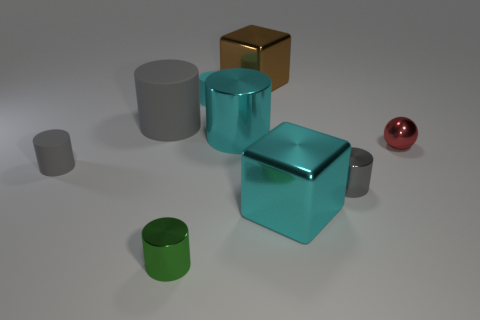Subtract all red spheres. How many gray cylinders are left? 3 Subtract all small cyan cylinders. How many cylinders are left? 5 Subtract all green cylinders. How many cylinders are left? 5 Subtract all red cylinders. Subtract all red spheres. How many cylinders are left? 6 Add 1 small purple matte cylinders. How many objects exist? 10 Subtract all cylinders. How many objects are left? 3 Add 8 tiny green things. How many tiny green things exist? 9 Subtract 0 green spheres. How many objects are left? 9 Subtract all green metallic cylinders. Subtract all tiny rubber cylinders. How many objects are left? 6 Add 8 tiny cyan rubber things. How many tiny cyan rubber things are left? 9 